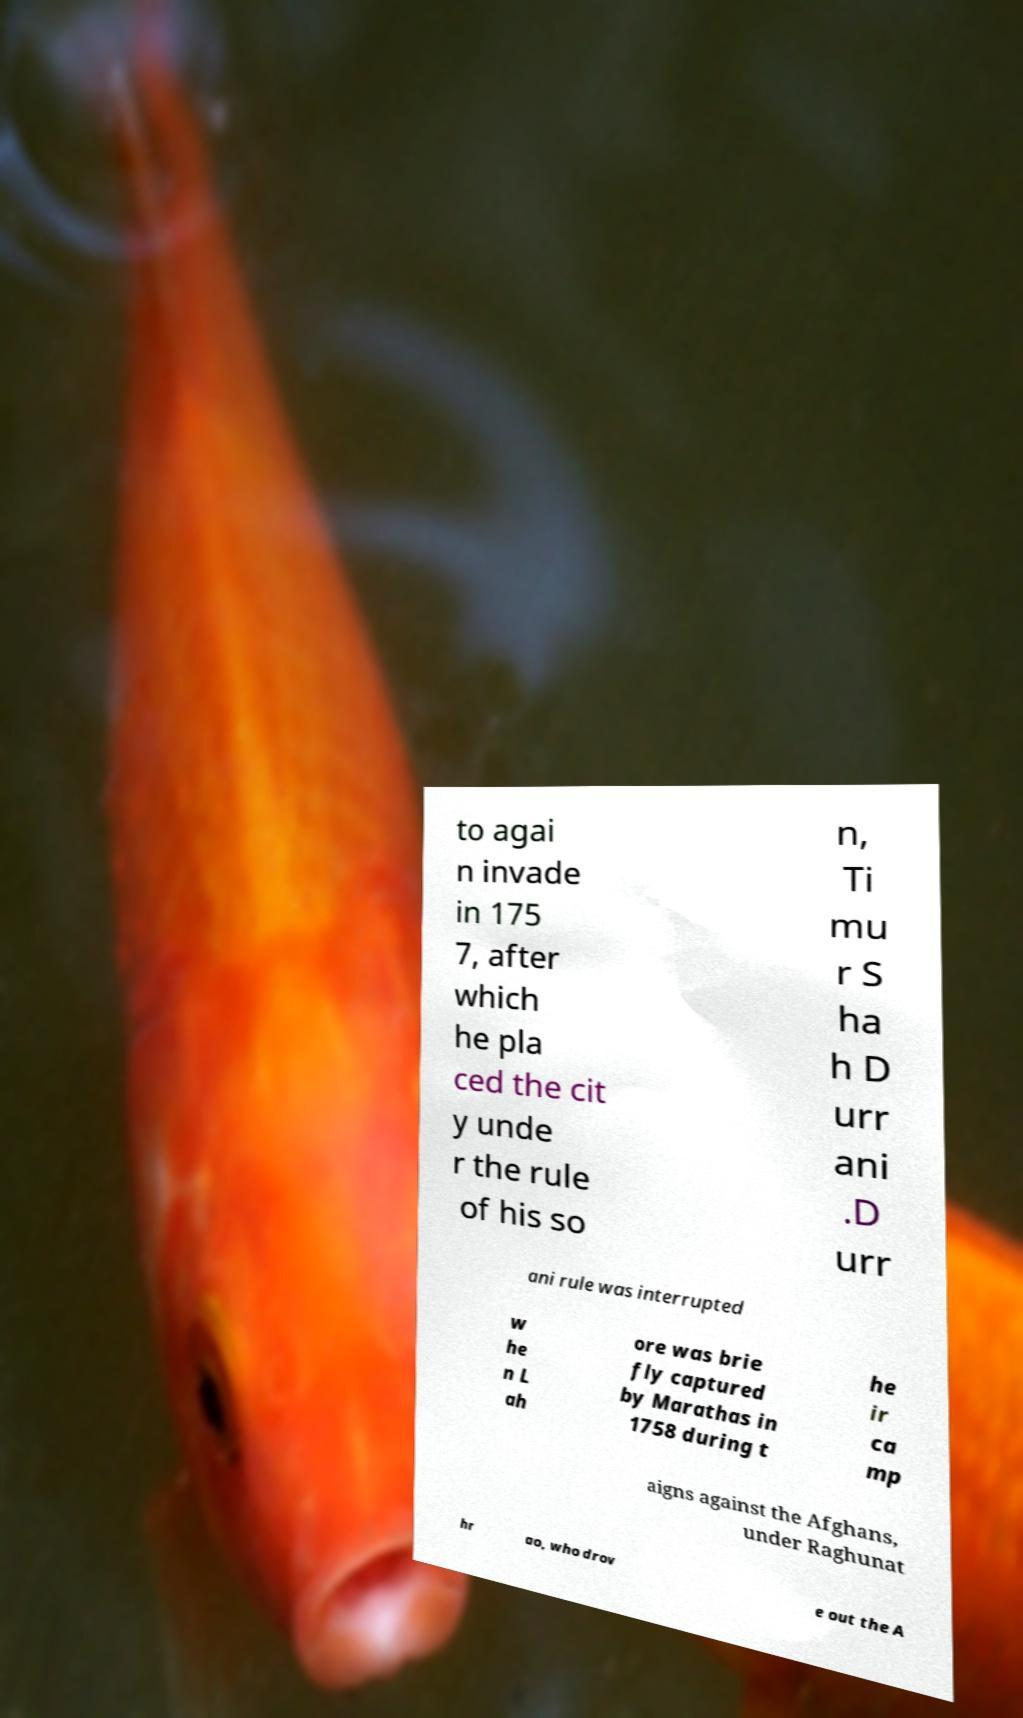Could you extract and type out the text from this image? to agai n invade in 175 7, after which he pla ced the cit y unde r the rule of his so n, Ti mu r S ha h D urr ani .D urr ani rule was interrupted w he n L ah ore was brie fly captured by Marathas in 1758 during t he ir ca mp aigns against the Afghans, under Raghunat hr ao, who drov e out the A 